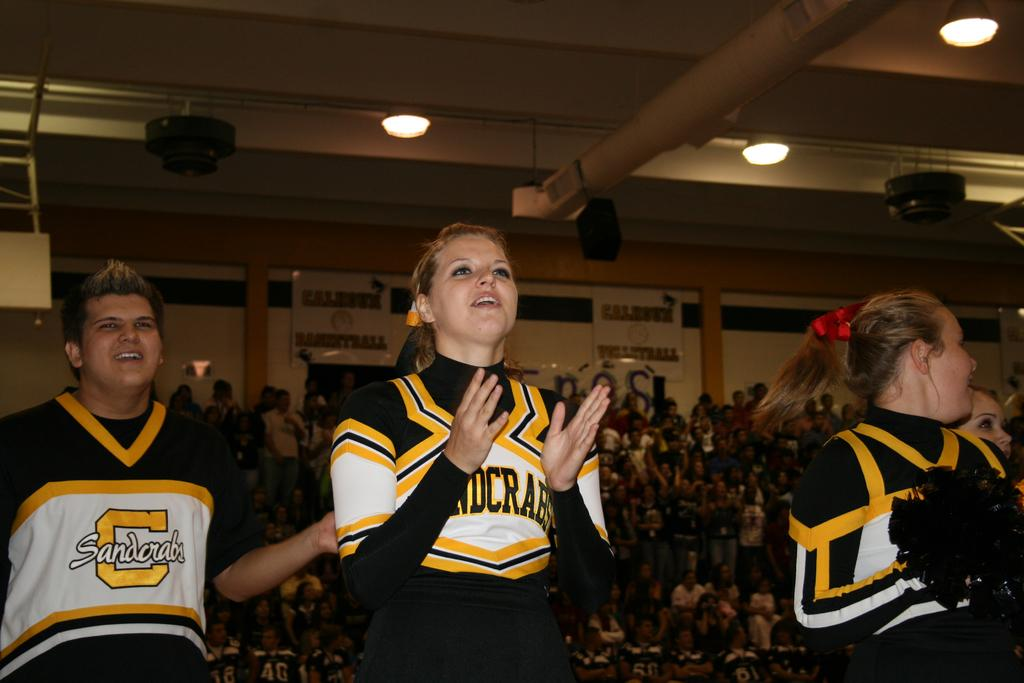<image>
Provide a brief description of the given image. Cheerleaders are cheering at a game for the Sandcrabs team. 